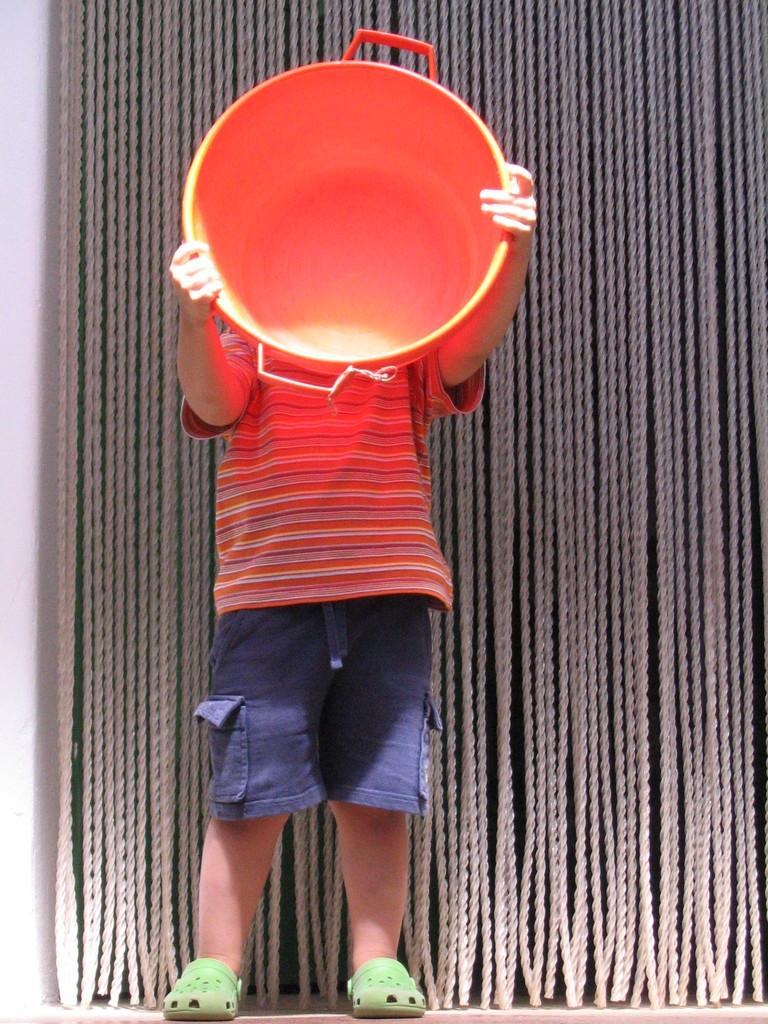How would you summarize this image in a sentence or two? This picture seems to be clicked inside. In the center there is a kid wearing t-shirt, standing and holding a vessel. In the background we can see the white color object seems to be the wall and we can see the hanging ropes. 